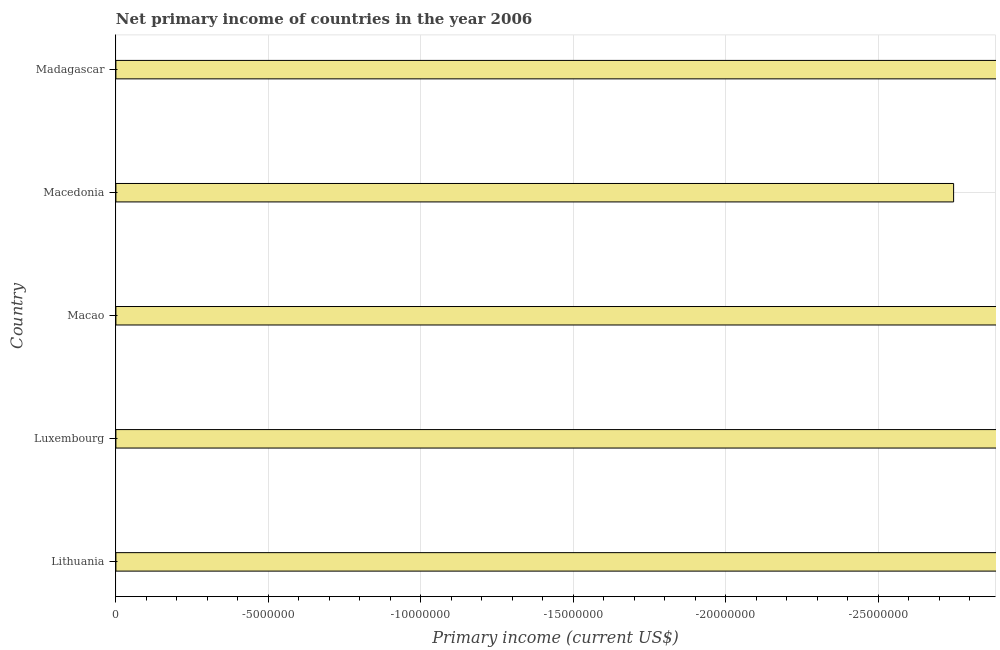What is the title of the graph?
Your answer should be very brief. Net primary income of countries in the year 2006. What is the label or title of the X-axis?
Make the answer very short. Primary income (current US$). What is the median amount of primary income?
Offer a very short reply. 0. How many bars are there?
Offer a terse response. 0. How many countries are there in the graph?
Make the answer very short. 5. What is the difference between two consecutive major ticks on the X-axis?
Provide a succinct answer. 5.00e+06. What is the Primary income (current US$) in Madagascar?
Your answer should be very brief. 0. 